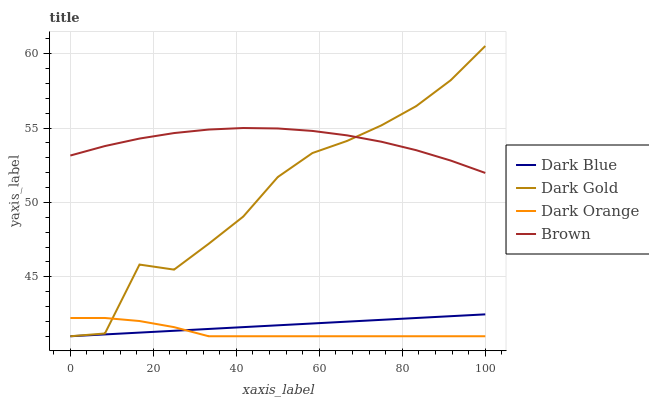Does Dark Orange have the minimum area under the curve?
Answer yes or no. Yes. Does Brown have the maximum area under the curve?
Answer yes or no. Yes. Does Dark Blue have the minimum area under the curve?
Answer yes or no. No. Does Dark Blue have the maximum area under the curve?
Answer yes or no. No. Is Dark Blue the smoothest?
Answer yes or no. Yes. Is Dark Gold the roughest?
Answer yes or no. Yes. Is Brown the smoothest?
Answer yes or no. No. Is Brown the roughest?
Answer yes or no. No. Does Dark Orange have the lowest value?
Answer yes or no. Yes. Does Brown have the lowest value?
Answer yes or no. No. Does Dark Gold have the highest value?
Answer yes or no. Yes. Does Dark Blue have the highest value?
Answer yes or no. No. Is Dark Orange less than Brown?
Answer yes or no. Yes. Is Brown greater than Dark Blue?
Answer yes or no. Yes. Does Brown intersect Dark Gold?
Answer yes or no. Yes. Is Brown less than Dark Gold?
Answer yes or no. No. Is Brown greater than Dark Gold?
Answer yes or no. No. Does Dark Orange intersect Brown?
Answer yes or no. No. 